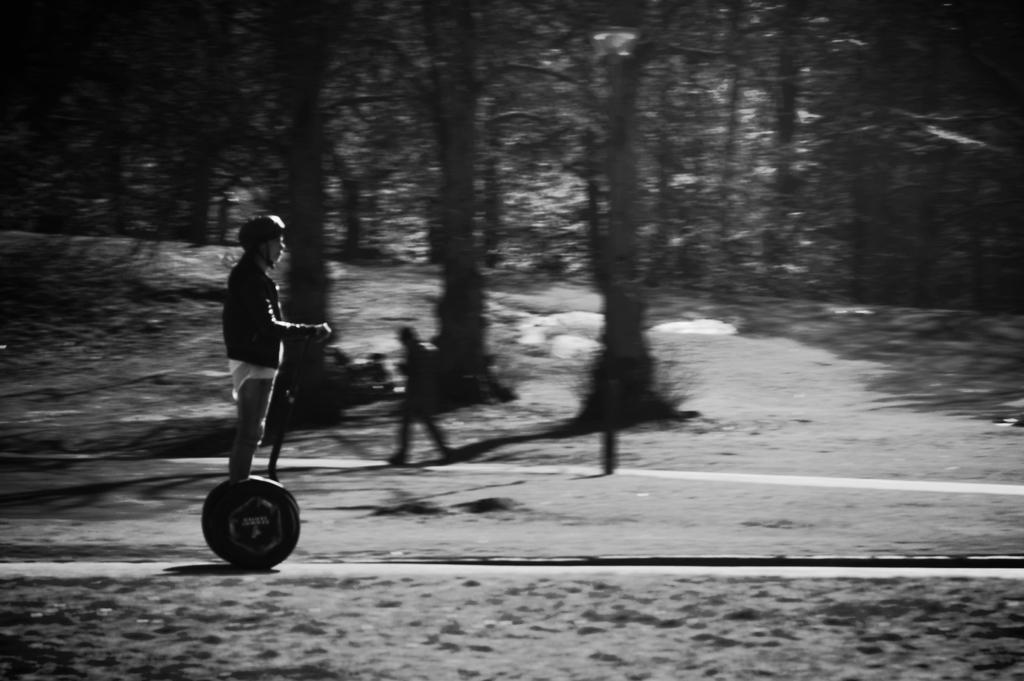What is the main subject of the image? There is a person riding a scooter in the image. What can be seen in the background of the image? There are trees and a person walking in the background of the image. What type of eggs is the queen holding in the image? There is no queen or eggs present in the image. Can you describe the wave pattern on the scooter in the image? There is no wave pattern mentioned on the scooter in the provided facts. 